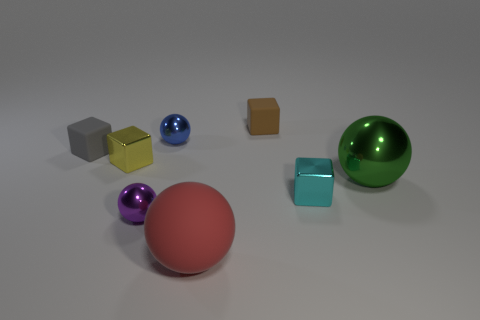Subtract all small gray cubes. How many cubes are left? 3 Add 2 big metallic balls. How many objects exist? 10 Subtract all red spheres. How many spheres are left? 3 Subtract all brown spheres. Subtract all purple cylinders. How many spheres are left? 4 Subtract all small cyan blocks. Subtract all small brown matte objects. How many objects are left? 6 Add 8 blue metal objects. How many blue metal objects are left? 9 Add 6 cyan metal blocks. How many cyan metal blocks exist? 7 Subtract 0 purple cubes. How many objects are left? 8 